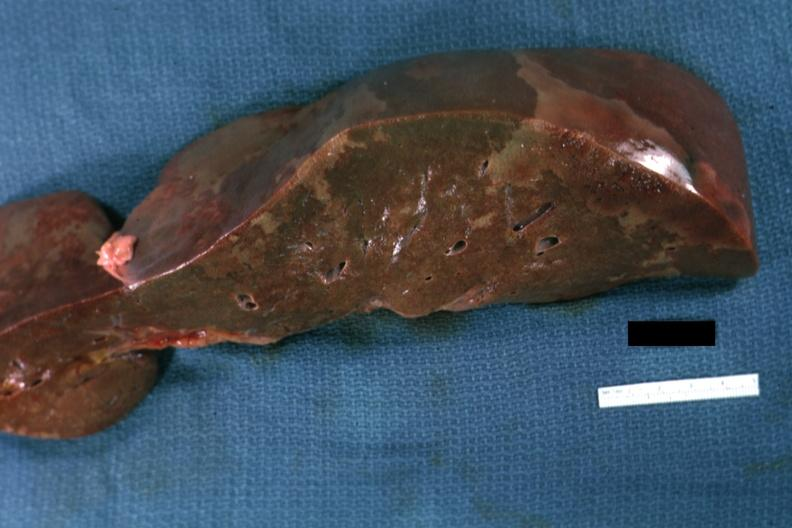what is present?
Answer the question using a single word or phrase. Hepatobiliary 